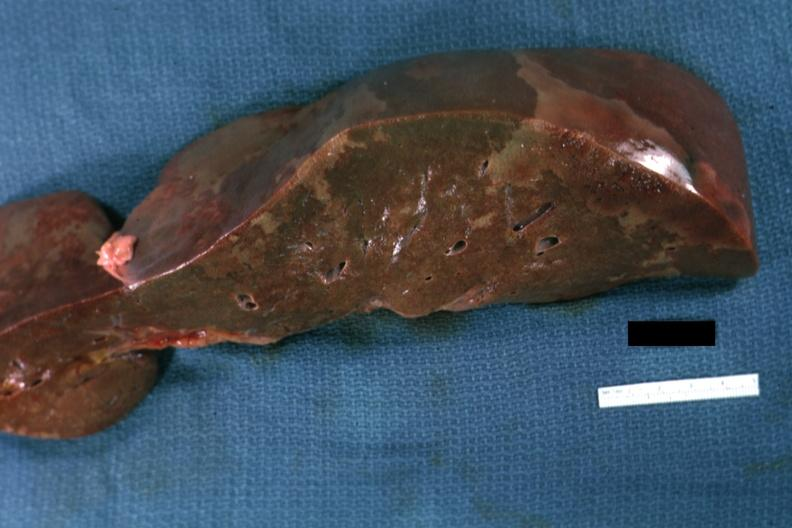what is present?
Answer the question using a single word or phrase. Hepatobiliary 